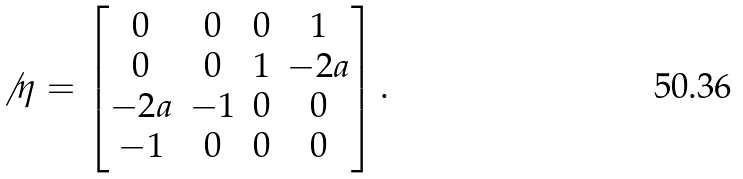Convert formula to latex. <formula><loc_0><loc_0><loc_500><loc_500>\not \, \eta = \begin{bmatrix} 0 & 0 & 0 & 1 \\ 0 & 0 & 1 & - 2 a \\ - 2 a & - 1 & 0 & 0 \\ - 1 & 0 & 0 & 0 \end{bmatrix} .</formula> 